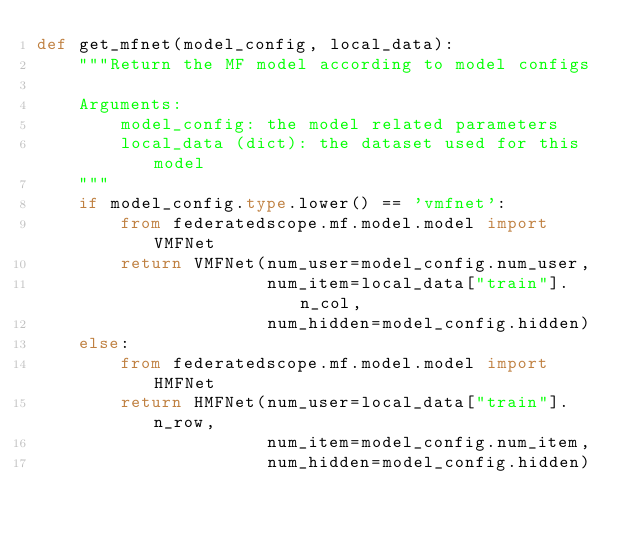Convert code to text. <code><loc_0><loc_0><loc_500><loc_500><_Python_>def get_mfnet(model_config, local_data):
    """Return the MF model according to model configs

    Arguments:
        model_config: the model related parameters
        local_data (dict): the dataset used for this model
    """
    if model_config.type.lower() == 'vmfnet':
        from federatedscope.mf.model.model import VMFNet
        return VMFNet(num_user=model_config.num_user,
                      num_item=local_data["train"].n_col,
                      num_hidden=model_config.hidden)
    else:
        from federatedscope.mf.model.model import HMFNet
        return HMFNet(num_user=local_data["train"].n_row,
                      num_item=model_config.num_item,
                      num_hidden=model_config.hidden)
</code> 